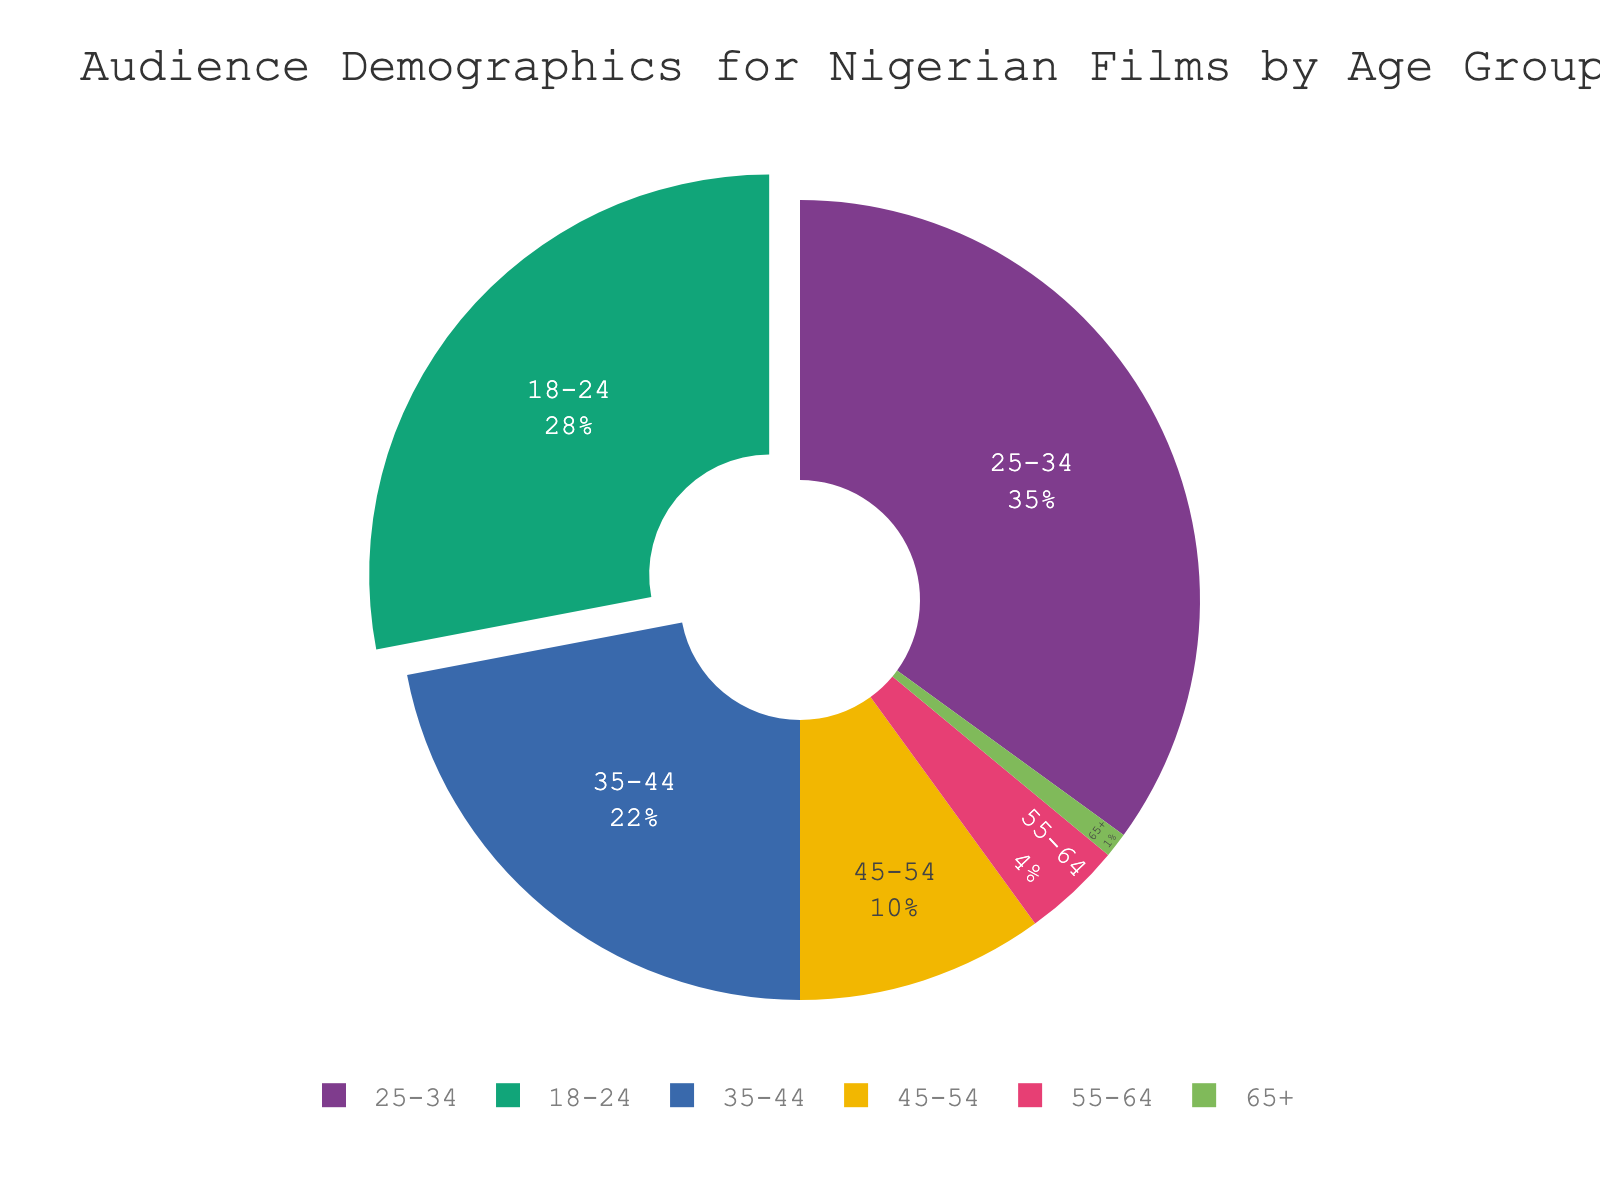Which age group has the highest percentage of the audience? The pie chart shows various age groups with their respective percentage shares. The age group 25-34 occupies the largest segment.
Answer: 25-34 What percentage of the audience is aged 45 and above? Sum the percentages of the age groups 45-54 (10%), 55-64 (4%), and 65+ (1%). 10% + 4% + 1% = 15%.
Answer: 15% Compare the percentages of the age groups 18-24 and 35-44. Which is larger, and by how much? The percentage for 18-24 is 28% and for 35-44 it is 22%. The difference is 28% - 22% = 6%.
Answer: 18-24 is larger by 6% What is the combined percentage of the audience aged 18-24 and 25-34? Sum the percentages of the age groups 18-24 (28%) and 25-34 (35%). 28% + 35% = 63%.
Answer: 63% How does the size of the audience aged 65+ compare to that of other age groups visually in the chart? The segment for 65+ is the smallest, approximately 1% and barely noticeable compared to other larger segments like 25-34.
Answer: 65+ is the smallest segment If you grouped the data into 'Under 35' and '35 and Above,' what percentage of the audience falls into each group? Sum the percentages for under 35 (18-24: 28%, 25-34: 35%) which is 63%. For 35 and above (35-44: 22%, 45-54: 10%, 55-64: 4%, 65+: 1%), sum is 37%.
Answer: Under 35: 63%, 35 and Above: 37% What's the total percentage of the audience aged 35-54? Sum the percentages of the age groups 35-44 (22%) and 45-54 (10%). 22% + 10% = 32%.
Answer: 32% Which age group has less than half the audience share of the 25-34 age group? The 25-34 age group is 35%. Half of 35% is 17.5%. The groups with less than 17.5% are 35-44 (22%), 45-54 (10%), 55-64 (4%), and 65+ (1%).
Answer: 45-54, 55-64, 65+ If you consider only the audience under 55 years old, what fraction of them are between 25-34 years? The audience under 55 years old includes 18-24 (28%), 25-34 (35%), 35-44 (22%), and 45-54 (10%). Sum is 95%. The fraction for 25-34 years is 35%/95%. Simplify the fraction.
Answer: 35/95 which simplifies to 7/19 Which age group accounts for 22% of the audience? The pie chart shows the age group 35-44 occupying 22% of the audience.
Answer: 35-44 